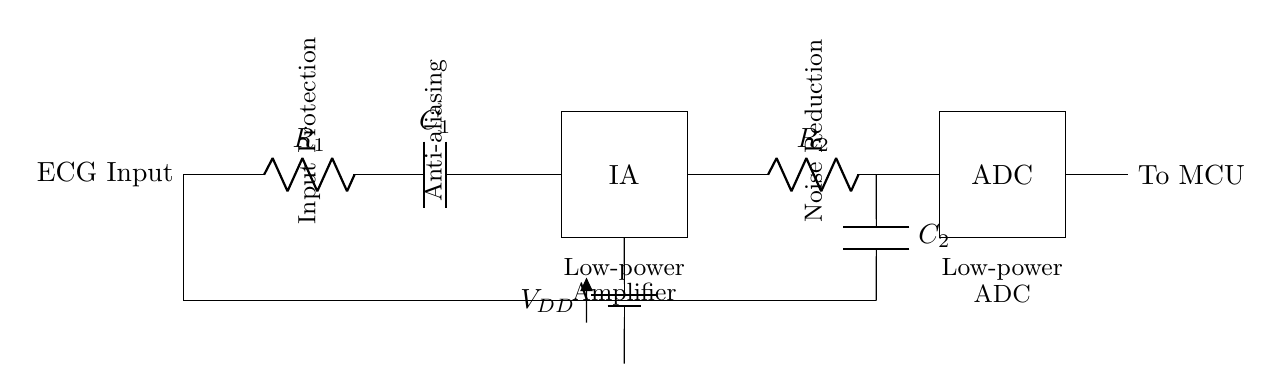What type of input is this circuit designed for? The circuit is designed for an ECG input, which is indicated by the label "ECG Input" on the left side of the diagram.
Answer: ECG Input What is the function of the instrumentation amplifier in this circuit? The instrumentation amplifier, labeled IA, amplifies the input ECG signal while minimizing noise, which is a critical function in medical signal processing.
Answer: Amplification Which component is used for anti-aliasing in this circuit? The component used for anti-aliasing is the capacitor labeled C1, which helps to filter out high-frequency noise before the signal is amplified.
Answer: C1 What is the purpose of the low-pass filter in this circuit? The low-pass filter, consisting of resistor R2 and capacitor C2, is used to reduce high-frequency noise from the amplified ECG signal before it is fed to the ADC, ensuring cleaner data is captured.
Answer: Noise Reduction What type of power supply is indicated in this circuit? The power supply indicated is a battery, represented by "V_DD," which suggests a portable and low-power solution suitable for wearable devices.
Answer: Battery What does ADC stand for in this context? ADC stands for Analog-to-Digital Converter, which is responsible for converting the analog ECG signal into a digital format that can be processed by a microcontroller.
Answer: Analog-to-Digital Converter What kind of components are used to ensure low power consumption in this design? The design incorporates low-power components, specifically labeled as "Low-power Amplifier" and "Low-power ADC," indicating that both the amplification and conversion stages are optimized for energy efficiency.
Answer: Low-power components 